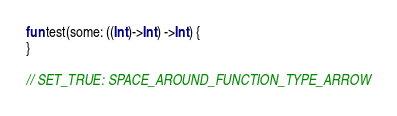Convert code to text. <code><loc_0><loc_0><loc_500><loc_500><_Kotlin_>fun test(some: ((Int)->Int) ->Int) {
}

// SET_TRUE: SPACE_AROUND_FUNCTION_TYPE_ARROW</code> 